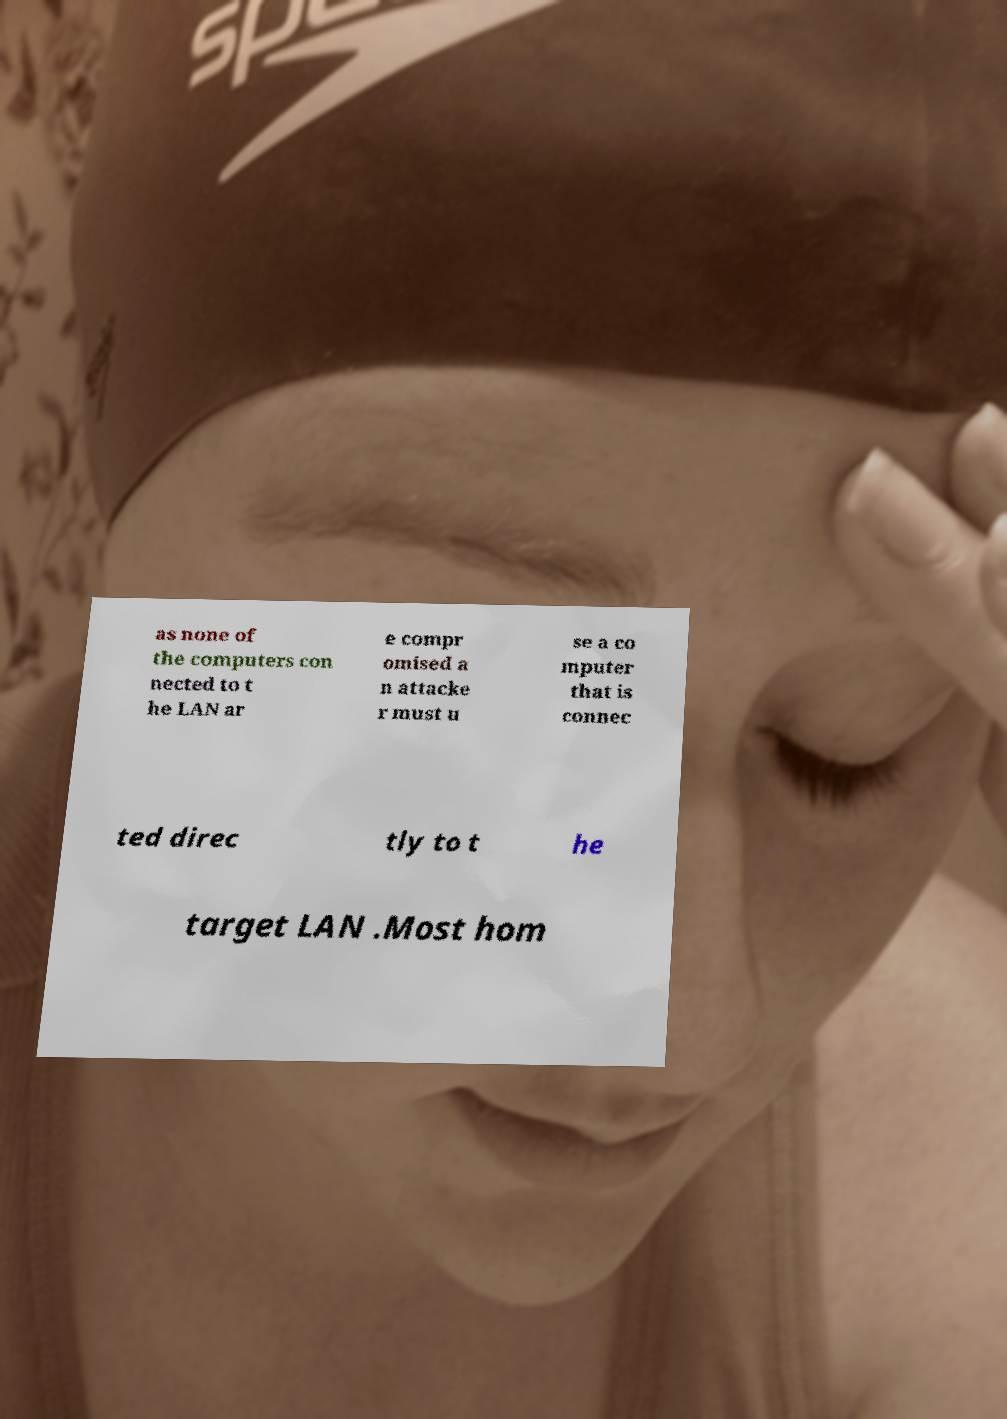I need the written content from this picture converted into text. Can you do that? as none of the computers con nected to t he LAN ar e compr omised a n attacke r must u se a co mputer that is connec ted direc tly to t he target LAN .Most hom 